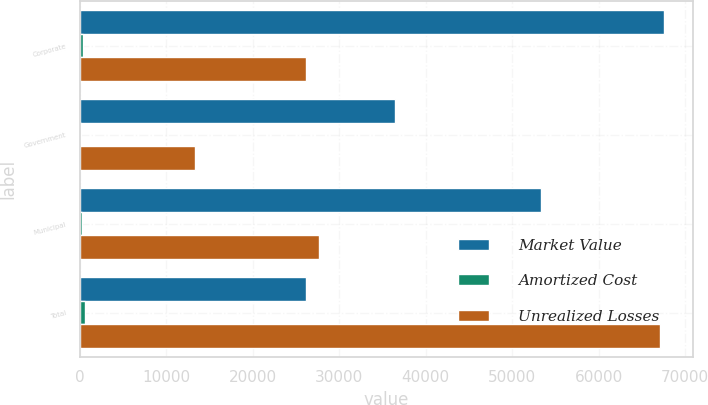<chart> <loc_0><loc_0><loc_500><loc_500><stacked_bar_chart><ecel><fcel>Corporate<fcel>Government<fcel>Municipal<fcel>Total<nl><fcel>Market Value<fcel>67549<fcel>36472<fcel>53343<fcel>26151<nl><fcel>Amortized Cost<fcel>313<fcel>110<fcel>196<fcel>619<nl><fcel>Unrealized Losses<fcel>26151<fcel>13309<fcel>27646<fcel>67106<nl></chart> 